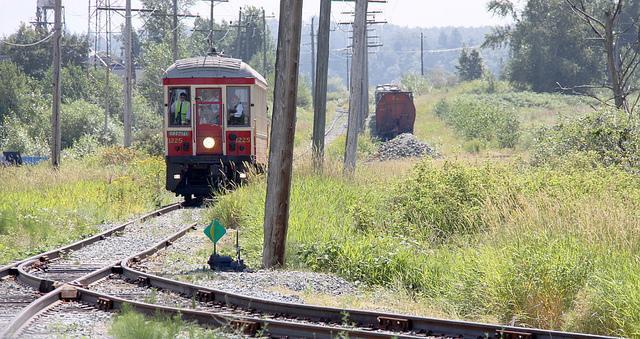How many lights are on the train?
Give a very brief answer. 1. How many trains are there?
Give a very brief answer. 2. How many people are wearing a tie in the picture?
Give a very brief answer. 0. 